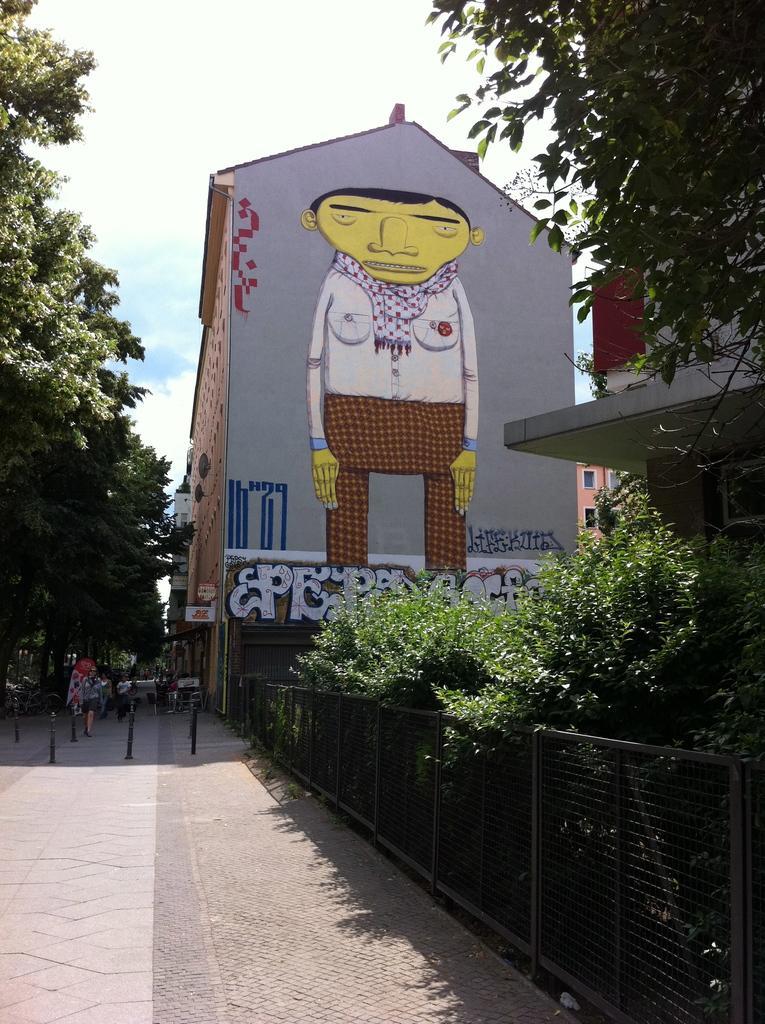Can you describe this image briefly? On the right side of the picture there are plants, trees, buildings and painting. On the left side there is pavement, on the payment there are people and vehicles. At the top left there are trees. In the center of the background there is a building, on the building there is a person's painting. It is sunny. 